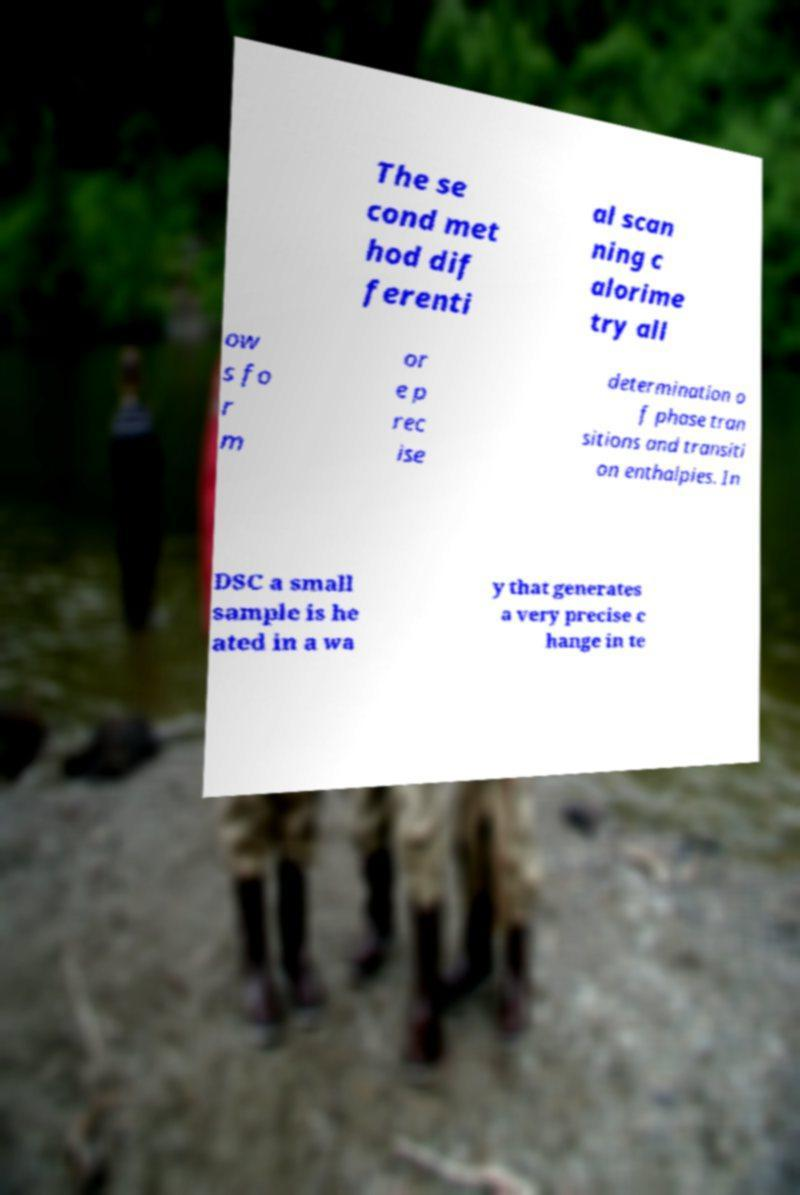What messages or text are displayed in this image? I need them in a readable, typed format. The se cond met hod dif ferenti al scan ning c alorime try all ow s fo r m or e p rec ise determination o f phase tran sitions and transiti on enthalpies. In DSC a small sample is he ated in a wa y that generates a very precise c hange in te 